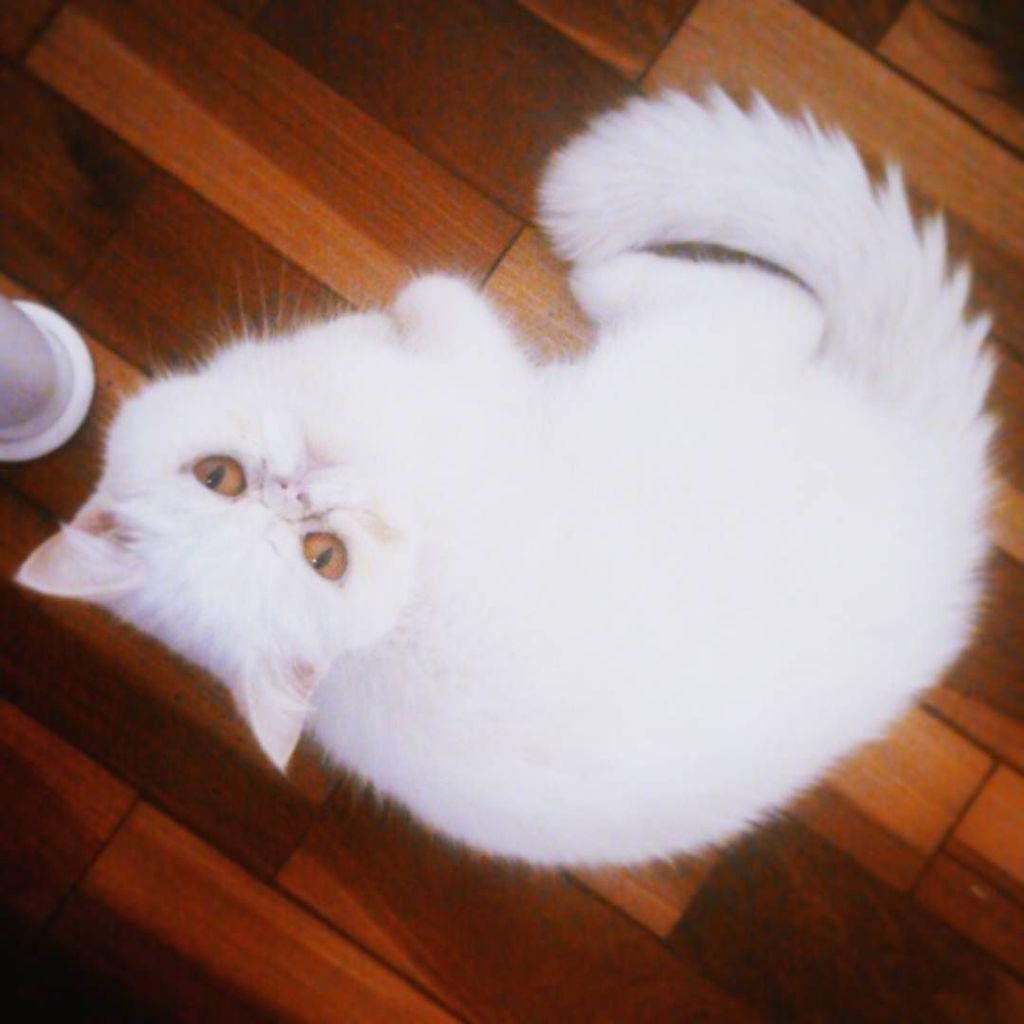What type of animal is in the image? There is a white-colored cat in the image. Where is the cat located in the image? The cat is present on the floor. What type of liquid is the cat drinking in the image? There is no liquid present in the image; it is a white-colored cat on the floor. 